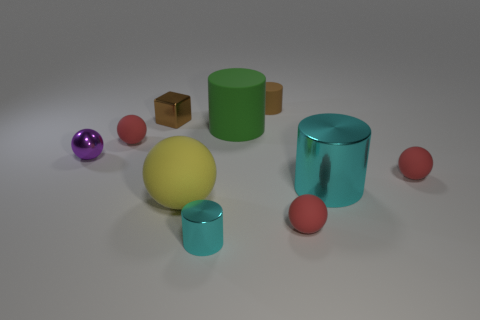There is a matte thing that is the same color as the metallic block; what size is it?
Your answer should be compact. Small. There is a sphere that is on the right side of the big cyan object; is its color the same as the tiny matte object that is in front of the big cyan metallic cylinder?
Keep it short and to the point. Yes. Is the shape of the tiny matte thing in front of the large cyan cylinder the same as the small matte thing that is on the left side of the large green cylinder?
Ensure brevity in your answer.  Yes. What is the material of the large yellow ball?
Provide a short and direct response. Rubber. There is a red thing that is to the left of the small matte cylinder; what is it made of?
Offer a terse response. Rubber. Is there any other thing that has the same color as the small metal ball?
Ensure brevity in your answer.  No. There is a yellow ball that is the same material as the large green thing; what is its size?
Give a very brief answer. Large. How many tiny things are rubber cubes or brown shiny blocks?
Offer a terse response. 1. There is a cyan object behind the large rubber object left of the cyan object that is on the left side of the big cyan cylinder; what is its size?
Ensure brevity in your answer.  Large. What number of purple cubes have the same size as the green matte cylinder?
Offer a terse response. 0. 